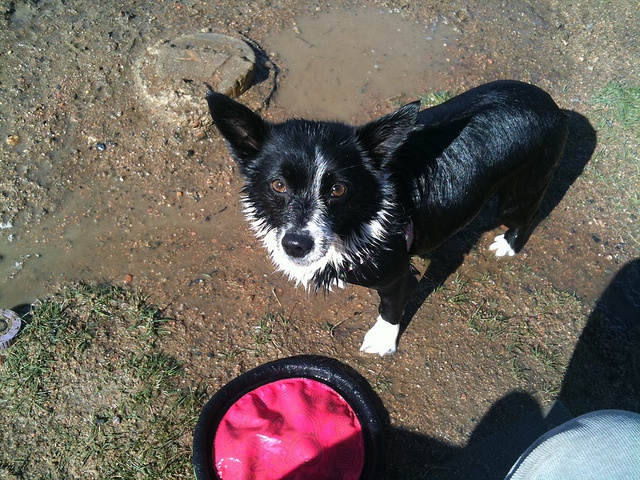Describe the objects in this image and their specific colors. I can see dog in gray, black, and white tones, frisbee in gray, black, violet, brown, and maroon tones, and people in gray, lightblue, and blue tones in this image. 